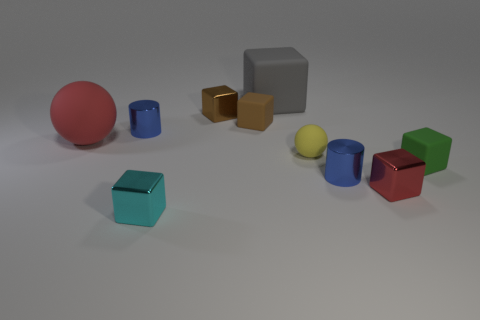How many cubes have the same material as the big ball?
Offer a very short reply. 3. There is a tiny matte cube that is on the left side of the red cube; how many small blue metallic cylinders are left of it?
Keep it short and to the point. 1. There is a small thing that is in front of the tiny red block; does it have the same color as the metal block behind the tiny green matte object?
Your answer should be very brief. No. The small metal thing that is both behind the tiny ball and right of the cyan block has what shape?
Your response must be concise. Cube. Is there a big cyan metal object of the same shape as the gray rubber thing?
Your response must be concise. No. What is the shape of the yellow object that is the same size as the red shiny thing?
Your response must be concise. Sphere. What is the large red object made of?
Provide a short and direct response. Rubber. What is the size of the shiny cylinder on the left side of the large object that is to the right of the small matte cube to the left of the green rubber object?
Offer a terse response. Small. There is a object that is the same color as the large sphere; what is its material?
Your answer should be very brief. Metal. What number of metal things are either cyan things or large red spheres?
Ensure brevity in your answer.  1. 